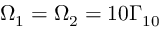Convert formula to latex. <formula><loc_0><loc_0><loc_500><loc_500>\Omega _ { 1 } = \Omega _ { 2 } = 1 0 \Gamma _ { 1 0 }</formula> 